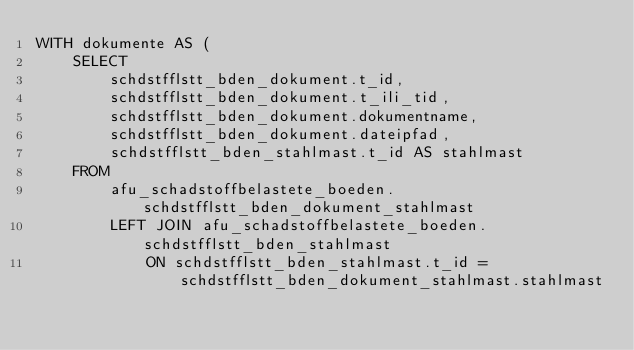<code> <loc_0><loc_0><loc_500><loc_500><_SQL_>WITH dokumente AS (
    SELECT
        schdstfflstt_bden_dokument.t_id,
        schdstfflstt_bden_dokument.t_ili_tid,
        schdstfflstt_bden_dokument.dokumentname,
        schdstfflstt_bden_dokument.dateipfad,
        schdstfflstt_bden_stahlmast.t_id AS stahlmast
    FROM
        afu_schadstoffbelastete_boeden.schdstfflstt_bden_dokument_stahlmast
        LEFT JOIN afu_schadstoffbelastete_boeden.schdstfflstt_bden_stahlmast
            ON schdstfflstt_bden_stahlmast.t_id = schdstfflstt_bden_dokument_stahlmast.stahlmast</code> 